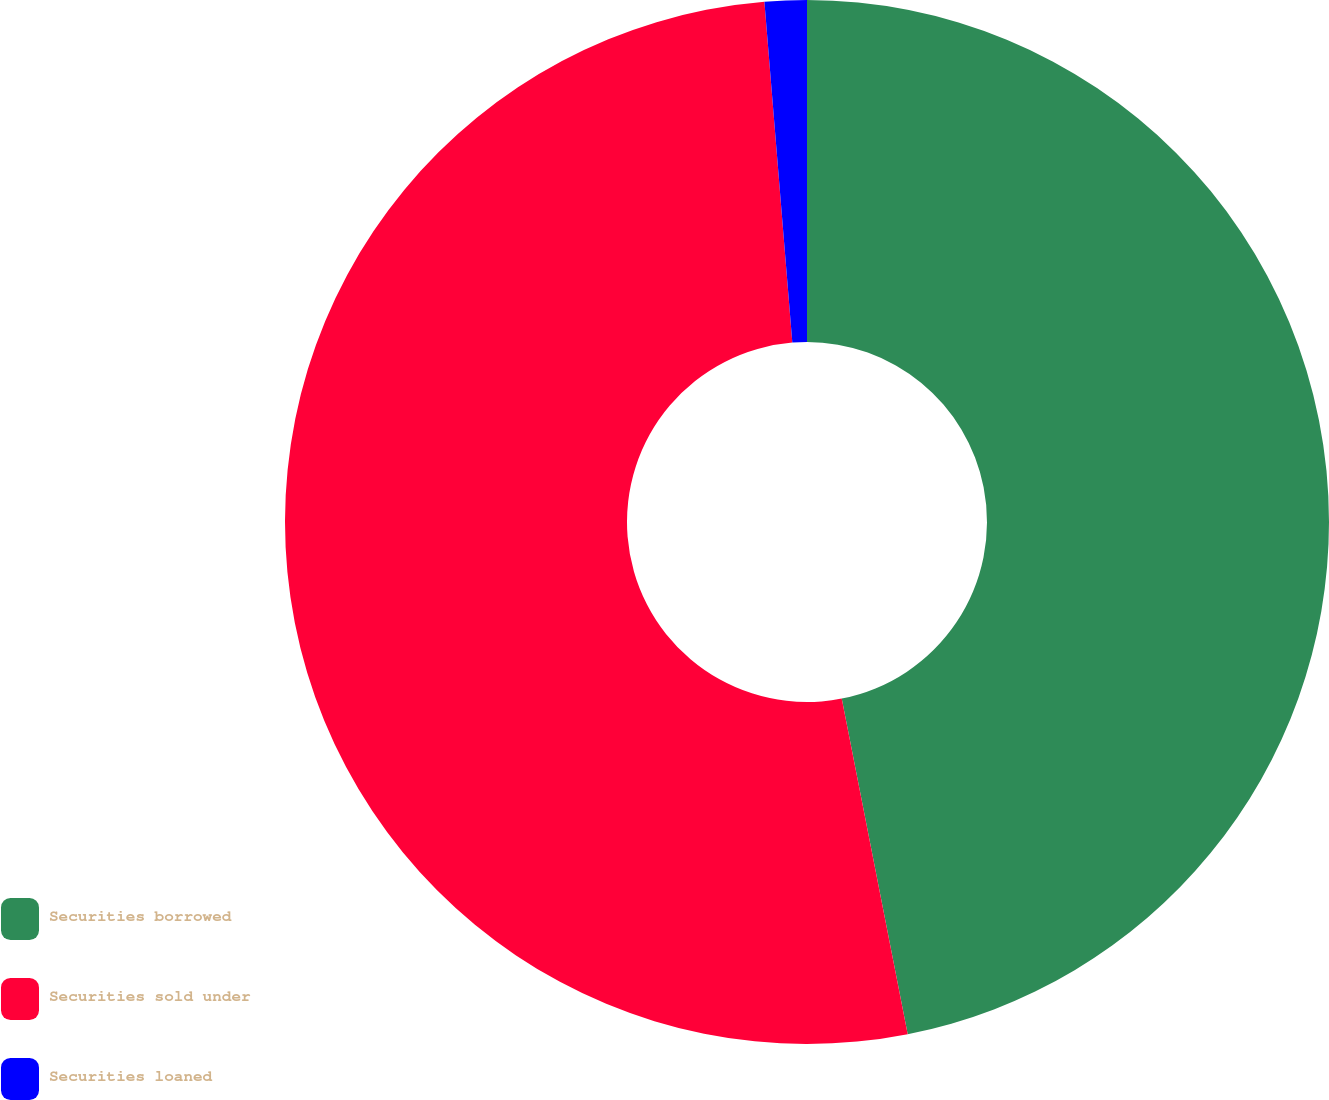<chart> <loc_0><loc_0><loc_500><loc_500><pie_chart><fcel>Securities borrowed<fcel>Securities sold under<fcel>Securities loaned<nl><fcel>46.91%<fcel>51.79%<fcel>1.3%<nl></chart> 